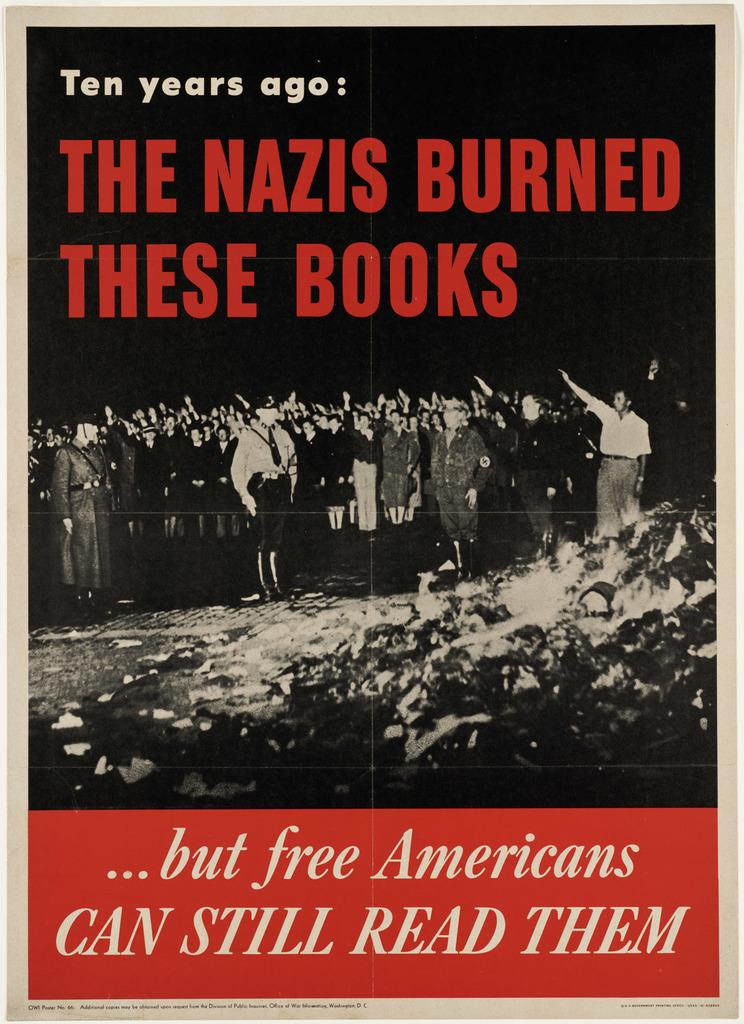<image>
Share a concise interpretation of the image provided. A poster proclaims that books burned by Nazis can still be read by free Americans. 